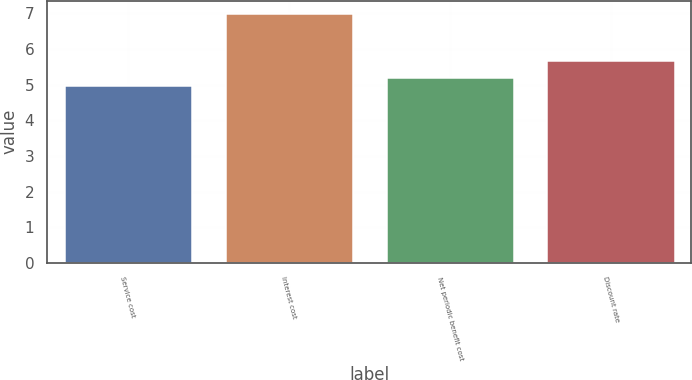Convert chart. <chart><loc_0><loc_0><loc_500><loc_500><bar_chart><fcel>Service cost<fcel>Interest cost<fcel>Net periodic benefit cost<fcel>Discount rate<nl><fcel>5<fcel>7<fcel>5.2<fcel>5.7<nl></chart> 